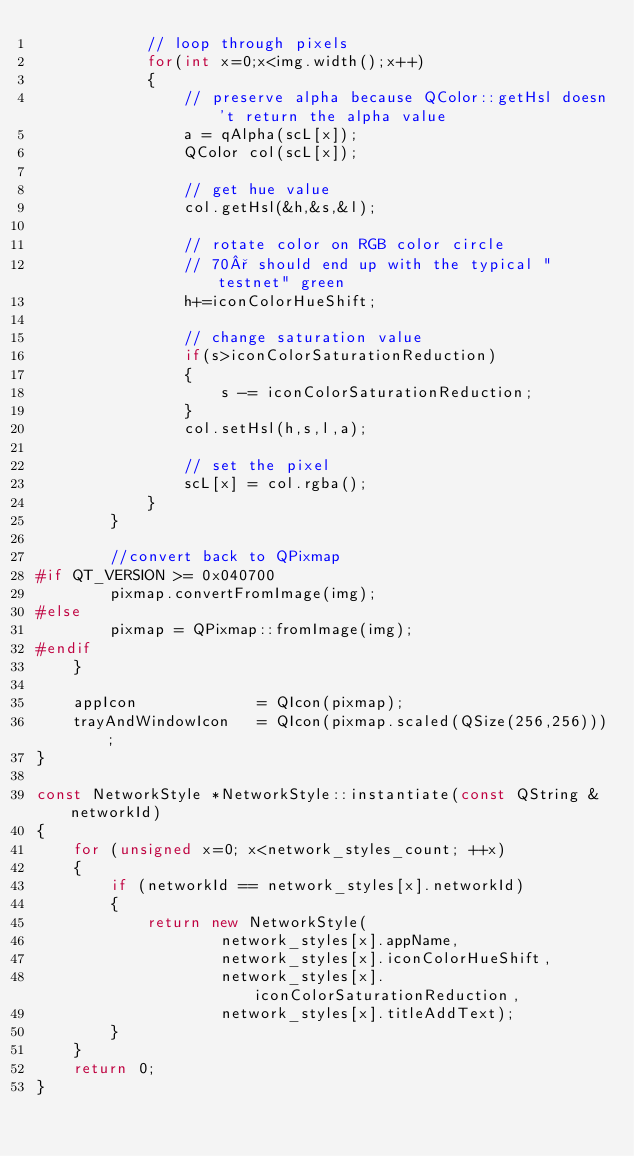Convert code to text. <code><loc_0><loc_0><loc_500><loc_500><_C++_>            // loop through pixels
            for(int x=0;x<img.width();x++)
            {
                // preserve alpha because QColor::getHsl doesn't return the alpha value
                a = qAlpha(scL[x]);
                QColor col(scL[x]);

                // get hue value
                col.getHsl(&h,&s,&l);

                // rotate color on RGB color circle
                // 70° should end up with the typical "testnet" green
                h+=iconColorHueShift;

                // change saturation value
                if(s>iconColorSaturationReduction)
                {
                    s -= iconColorSaturationReduction;
                }
                col.setHsl(h,s,l,a);

                // set the pixel
                scL[x] = col.rgba();
            }
        }

        //convert back to QPixmap
#if QT_VERSION >= 0x040700
        pixmap.convertFromImage(img);
#else
        pixmap = QPixmap::fromImage(img);
#endif
    }

    appIcon             = QIcon(pixmap);
    trayAndWindowIcon   = QIcon(pixmap.scaled(QSize(256,256)));
}

const NetworkStyle *NetworkStyle::instantiate(const QString &networkId)
{
    for (unsigned x=0; x<network_styles_count; ++x)
    {
        if (networkId == network_styles[x].networkId)
        {
            return new NetworkStyle(
                    network_styles[x].appName,
                    network_styles[x].iconColorHueShift,
                    network_styles[x].iconColorSaturationReduction,
                    network_styles[x].titleAddText);
        }
    }
    return 0;
}
</code> 